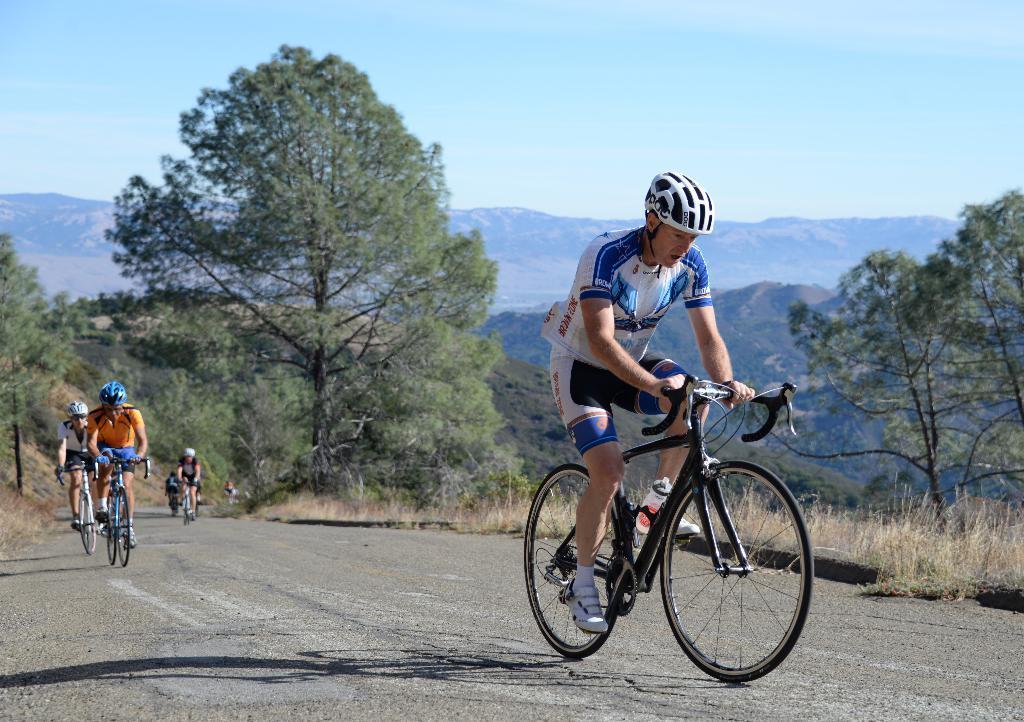How would you summarize this image in a sentence or two? In the picture we can see a person riding a bicycle and he is wearing a T-shirt and a helmet and behind him also we can see some people are riding bicycles and wearing helmets and in the background we can see grass, plants, trees, hills and sky. 